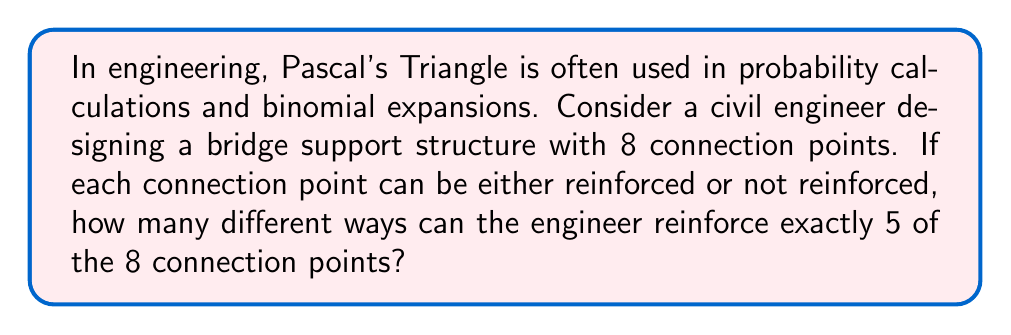Can you solve this math problem? To solve this problem, we need to understand the relationship between Pascal's Triangle and combinations.

1) First, let's recall that the numbers in Pascal's Triangle represent combinations. The entry in the $n$-th row and $k$-th position (both starting from 0) is equal to $\binom{n}{k}$, which represents the number of ways to choose $k$ items from $n$ items.

2) In this problem, we have:
   - $n = 8$ (total number of connection points)
   - $k = 5$ (number of points to be reinforced)

3) We are looking for $\binom{8}{5}$, which is the same as $\binom{8}{3}$ (because choosing 5 out of 8 to reinforce is the same as choosing 3 out of 8 to not reinforce).

4) To find this in Pascal's Triangle, we look at the 8th row (remembering that we start counting at 0):

   $$1 \quad 8 \quad 28 \quad 56 \quad 70 \quad 56 \quad 28 \quad 8 \quad 1$$

5) The number we're looking for is the 6th number in this row (again, counting from 0).

6) Therefore, $\binom{8}{5} = 56$

This means there are 56 different ways to reinforce exactly 5 out of 8 connection points.

Alternatively, we could calculate this directly using the combination formula:

$$\binom{8}{5} = \frac{8!}{5!(8-5)!} = \frac{8!}{5!3!} = \frac{8 \cdot 7 \cdot 6}{3 \cdot 2 \cdot 1} = 56$$

This method arrives at the same result, demonstrating the power and efficiency of using Pascal's Triangle in such calculations.
Answer: 56 ways 